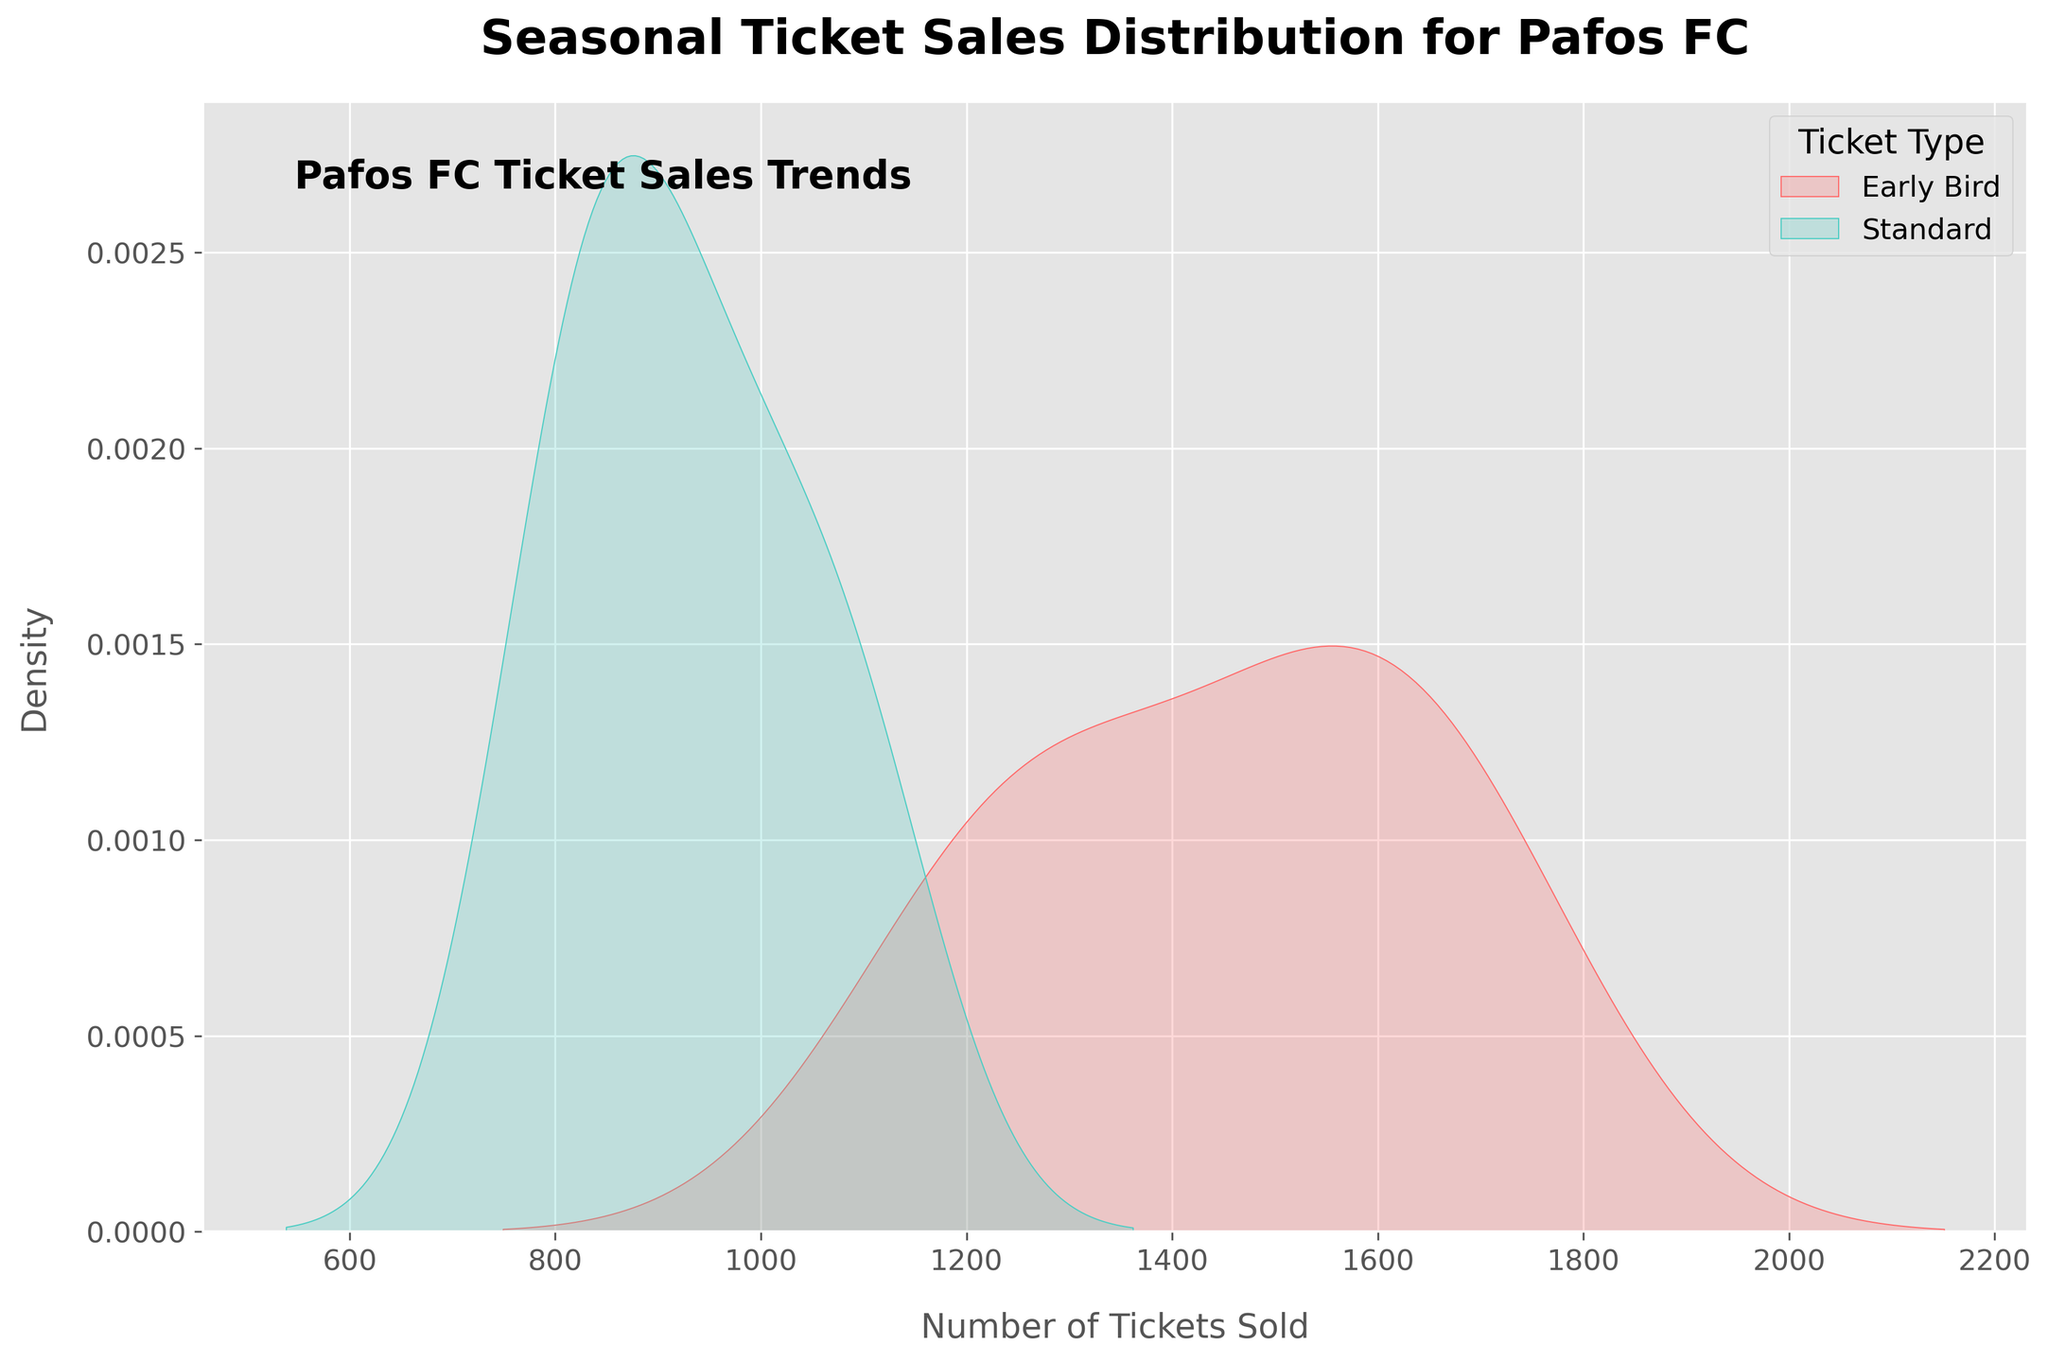What two types of ticket sales are shown in the figure? The figure has two types of ticket sales distributions distinguished by their label and color.
Answer: Early Bird and Standard What colors are used to represent Early Bird and Standard ticket sales? The plot uses different colors to represent the two types. Early Bird sales are shown in a reddish hue, and Standard sales in a turquoise hue.
Answer: Reddish and turquoise Which season has the highest density peak for Early Bird ticket sales? By comparing the KDE peak (highest point) locations for Early Bird sales, the highest density is in the 2022-2023 season.
Answer: 2022-2023 Compare the overall spread of Early Bird and Standard ticket sales. Which one is broader? Examining the KDE plots' spread and thickness: Early Bird sales show a wider spread across different ticket numbers compared to Standard sales.
Answer: Early Bird How does the ticket sales density for Standard tickets in the 2019-2020 season compare to the 2022-2023 season? The KDE plot shows higher density peaks toward higher ticket numbers in the 2022-2023 season compared to 2019-2020, indicating an increase.
Answer: Higher in 2022-2023 Are Early Bird ticket sales consistently higher than Standard ticket sales across seasons? Looking at the KDE plots for every season, Early Bird ticket sales consistently peak higher than Standard ticket sales.
Answer: Yes What's the range of ticket sales numbers shown for Early Bird tickets? Observing the KDE plot, the range where Early Bird sales densities are noticeable extends roughly from 1200 to 1700.
Answer: 1200 to 1700 Which type of ticket has a higher peak density for the 2021-2022 season? Refer to the KDE peaks, Early Bird ticket sales have a higher peak density than Standard ticket sales for the 2021-2022 season.
Answer: Early Bird What can be inferred about the trend in Early Bird ticket sales over the seasons? Inspecting the peak positions of Early Bird ticket sales in the KDE plots shows a steady increase across the seasons.
Answer: Increasing trend 